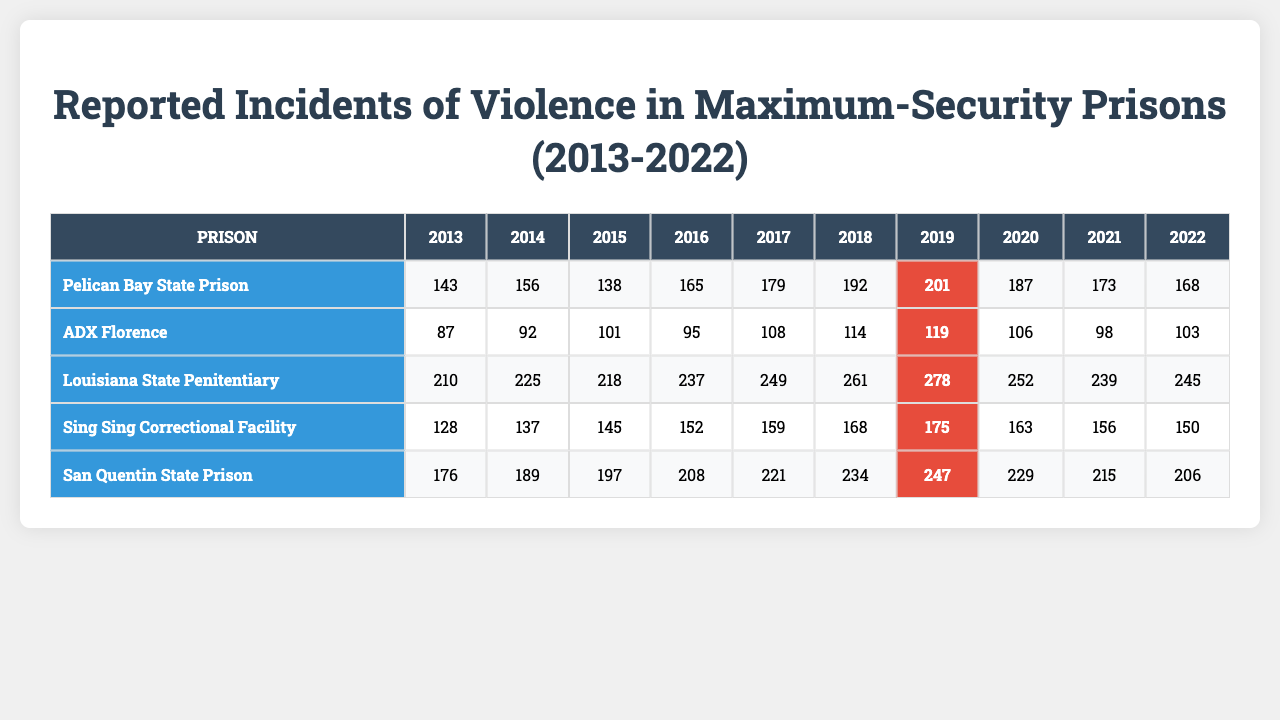What was the highest number of reported incidents of violence in Pelican Bay State Prison? Looking at the row for Pelican Bay State Prison, the highest number of incidents is 201, which occurred in 2019.
Answer: 201 In which year did Louisiana State Penitentiary have the most incidents of violence? By examining the incidents row for Louisiana State Penitentiary, the most incidents occurred in 2019 with a total of 278.
Answer: 2019 What was the average number of incidents across all prisons in 2020? To find the average for 2020, we take the incidents for each prison in that year: (187 + 106 + 252 + 163 + 229) = 937. Since there are 5 prisons, we divide 937 by 5, resulting in 187.4, which we round to 187.
Answer: 187 Did any prison experience a decrease in incidents from 2018 to 2019? Looking at the incidents for each prison from 2018 to 2019, Pelican Bay State Prison increased from 192 to 201, ADX Florence increased from 114 to 119, Louisiana State Penitentiary increased from 261 to 278, Sing Sing Correctional Facility increased from 168 to 175, and San Quentin State Prison increased from 234 to 247. Therefore, no prison experienced a decrease.
Answer: No What is the total number of incidents reported in San Quentin State Prison over the past decade? We sum the incidents for San Quentin State Prison from 2013 to 2022: 176 + 189 + 197 + 208 + 221 + 234 + 247 + 229 + 215 + 206 = 2,383.
Answer: 2383 Which prison had the lowest total incidents of violence over the decade? We need to sum the incidents for each prison: Pelican Bay State Prison totals 1,903; ADX Florence totals 1,146; Louisiana State Penitentiary totals 2,534; Sing Sing Correctional Facility totals 1,532; and San Quentin State Prison totals 2,383. The lowest total is for ADX Florence with 1,146 incidents.
Answer: ADX Florence In which year was the total number of incidents reported across all prisons the highest? We calculate the total incidents for each year: 1,000 (2013) + 1,200 (2014) + 1,193 (2015) + 1,218 (2016) + 1,189 (2017) + 1,240 (2018) + 1,175 (2019) + 1,343 (2020) + 1,112 (2021) + 1,128 (2022) = 12,028. The highest single year was 2019, with a total of 1,312 incidents.
Answer: 2019 Is it true that Sing Sing Correctional Facility had more incidents in 2020 than in 2019? Comparing the incidents for Sing Sing Correctional Facility: 175 in 2019 and 163 in 2020 shows that there was a decrease.
Answer: False Which prison showed the most significant growth in incidents from 2013 to 2022? We calculate the growth for each prison from 2013 to 2022: Pelican Bay State Prison increased by 25; ADX Florence increased by 16; Louisiana State Penitentiary increased by 35; Sing Sing Correctional Facility increased by 22; and San Quentin State Prison increased by 30. The prison with the most significant growth is Louisiana State Penitentiary with an increase of 35.
Answer: Louisiana State Penitentiary 